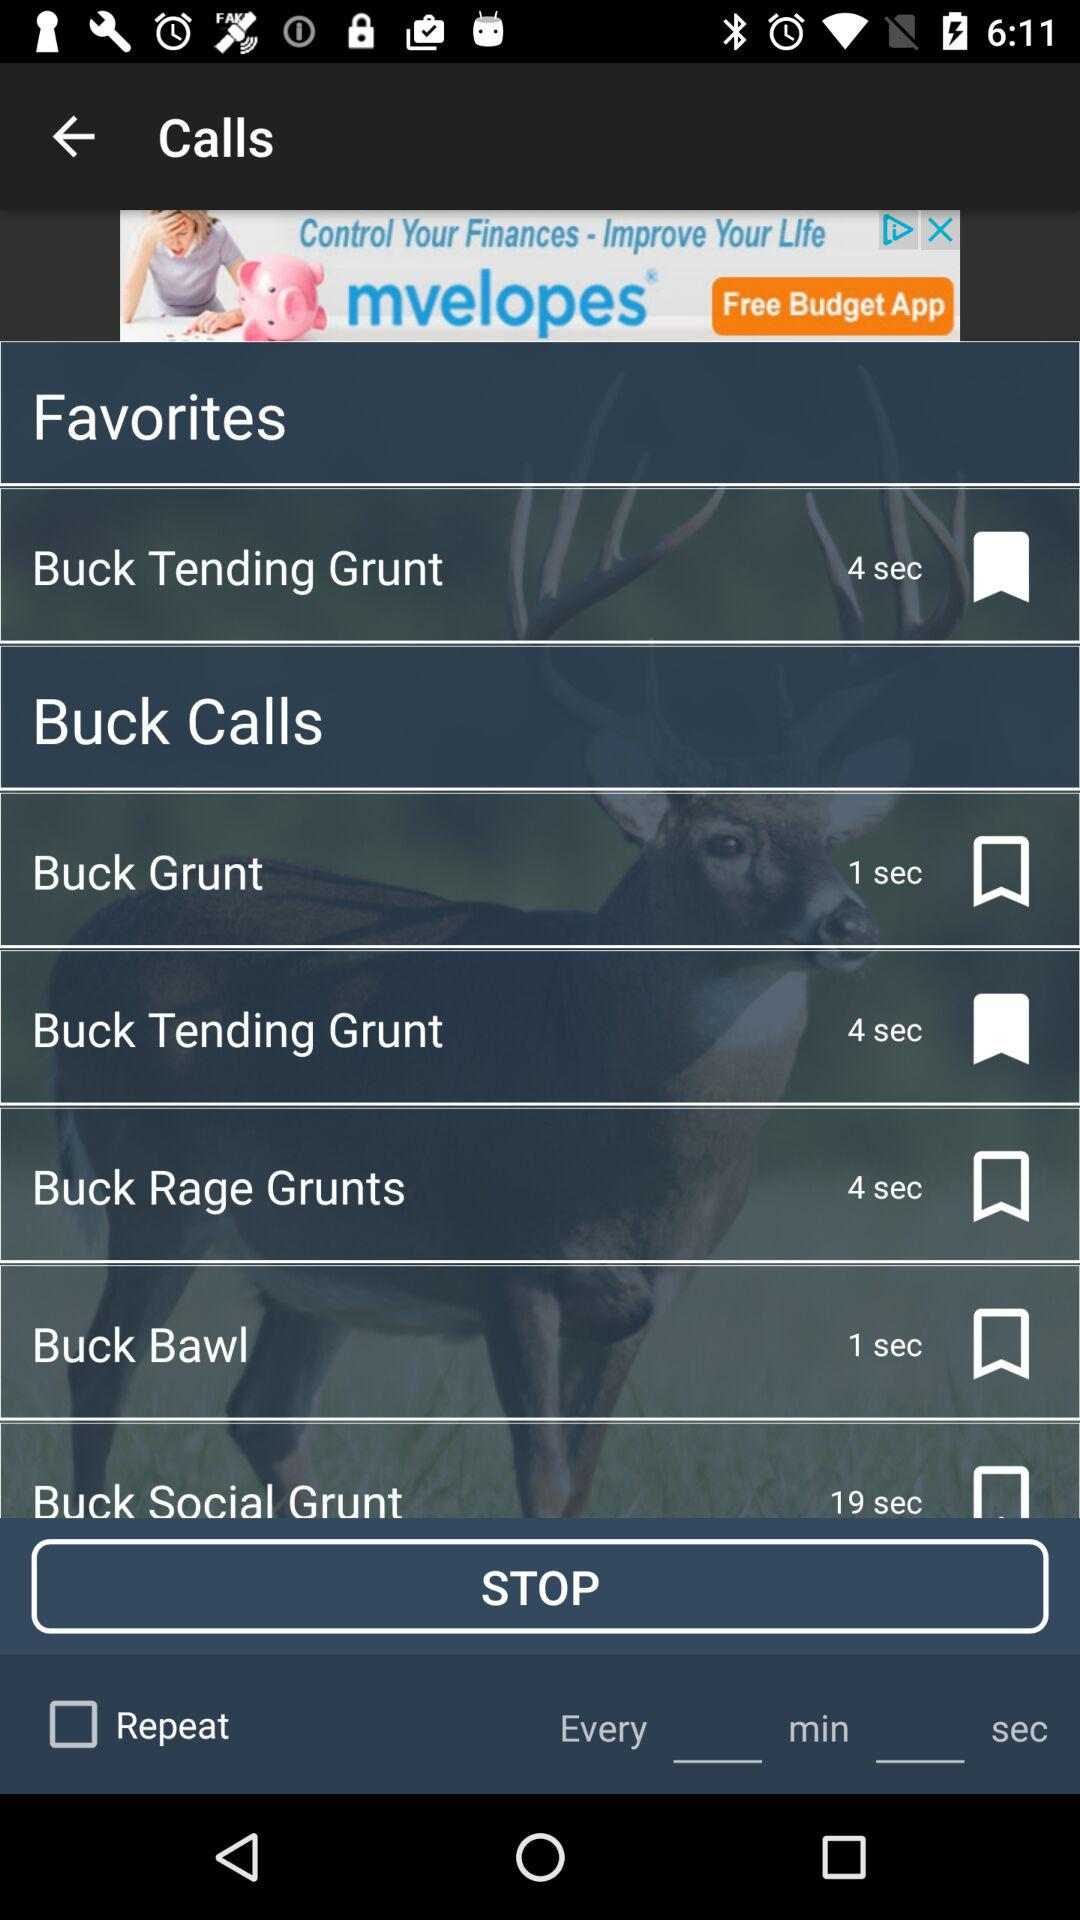Is "Buck Bawl" bookmarked or not? "Buck Bawl" is not bookmarked. 